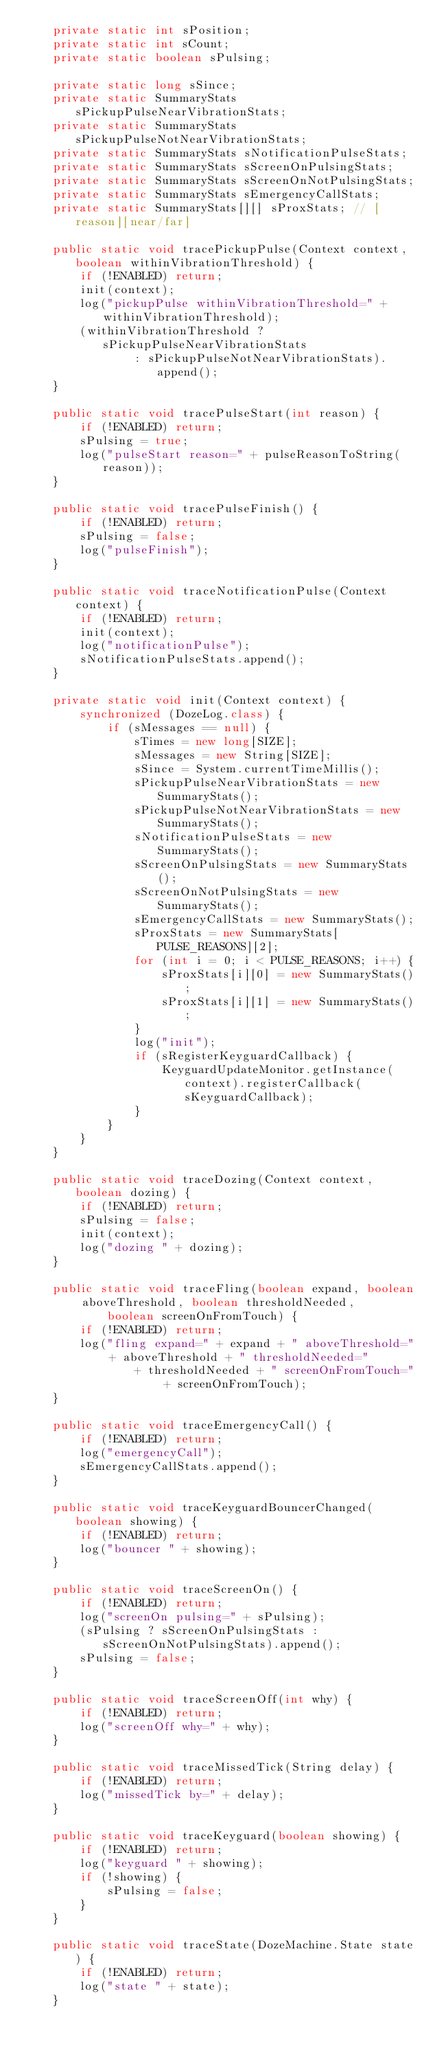<code> <loc_0><loc_0><loc_500><loc_500><_Java_>    private static int sPosition;
    private static int sCount;
    private static boolean sPulsing;

    private static long sSince;
    private static SummaryStats sPickupPulseNearVibrationStats;
    private static SummaryStats sPickupPulseNotNearVibrationStats;
    private static SummaryStats sNotificationPulseStats;
    private static SummaryStats sScreenOnPulsingStats;
    private static SummaryStats sScreenOnNotPulsingStats;
    private static SummaryStats sEmergencyCallStats;
    private static SummaryStats[][] sProxStats; // [reason][near/far]

    public static void tracePickupPulse(Context context, boolean withinVibrationThreshold) {
        if (!ENABLED) return;
        init(context);
        log("pickupPulse withinVibrationThreshold=" + withinVibrationThreshold);
        (withinVibrationThreshold ? sPickupPulseNearVibrationStats
                : sPickupPulseNotNearVibrationStats).append();
    }

    public static void tracePulseStart(int reason) {
        if (!ENABLED) return;
        sPulsing = true;
        log("pulseStart reason=" + pulseReasonToString(reason));
    }

    public static void tracePulseFinish() {
        if (!ENABLED) return;
        sPulsing = false;
        log("pulseFinish");
    }

    public static void traceNotificationPulse(Context context) {
        if (!ENABLED) return;
        init(context);
        log("notificationPulse");
        sNotificationPulseStats.append();
    }

    private static void init(Context context) {
        synchronized (DozeLog.class) {
            if (sMessages == null) {
                sTimes = new long[SIZE];
                sMessages = new String[SIZE];
                sSince = System.currentTimeMillis();
                sPickupPulseNearVibrationStats = new SummaryStats();
                sPickupPulseNotNearVibrationStats = new SummaryStats();
                sNotificationPulseStats = new SummaryStats();
                sScreenOnPulsingStats = new SummaryStats();
                sScreenOnNotPulsingStats = new SummaryStats();
                sEmergencyCallStats = new SummaryStats();
                sProxStats = new SummaryStats[PULSE_REASONS][2];
                for (int i = 0; i < PULSE_REASONS; i++) {
                    sProxStats[i][0] = new SummaryStats();
                    sProxStats[i][1] = new SummaryStats();
                }
                log("init");
                if (sRegisterKeyguardCallback) {
                    KeyguardUpdateMonitor.getInstance(context).registerCallback(sKeyguardCallback);
                }
            }
        }
    }

    public static void traceDozing(Context context, boolean dozing) {
        if (!ENABLED) return;
        sPulsing = false;
        init(context);
        log("dozing " + dozing);
    }

    public static void traceFling(boolean expand, boolean aboveThreshold, boolean thresholdNeeded,
            boolean screenOnFromTouch) {
        if (!ENABLED) return;
        log("fling expand=" + expand + " aboveThreshold=" + aboveThreshold + " thresholdNeeded="
                + thresholdNeeded + " screenOnFromTouch=" + screenOnFromTouch);
    }

    public static void traceEmergencyCall() {
        if (!ENABLED) return;
        log("emergencyCall");
        sEmergencyCallStats.append();
    }

    public static void traceKeyguardBouncerChanged(boolean showing) {
        if (!ENABLED) return;
        log("bouncer " + showing);
    }

    public static void traceScreenOn() {
        if (!ENABLED) return;
        log("screenOn pulsing=" + sPulsing);
        (sPulsing ? sScreenOnPulsingStats : sScreenOnNotPulsingStats).append();
        sPulsing = false;
    }

    public static void traceScreenOff(int why) {
        if (!ENABLED) return;
        log("screenOff why=" + why);
    }

    public static void traceMissedTick(String delay) {
        if (!ENABLED) return;
        log("missedTick by=" + delay);
    }

    public static void traceKeyguard(boolean showing) {
        if (!ENABLED) return;
        log("keyguard " + showing);
        if (!showing) {
            sPulsing = false;
        }
    }

    public static void traceState(DozeMachine.State state) {
        if (!ENABLED) return;
        log("state " + state);
    }
</code> 